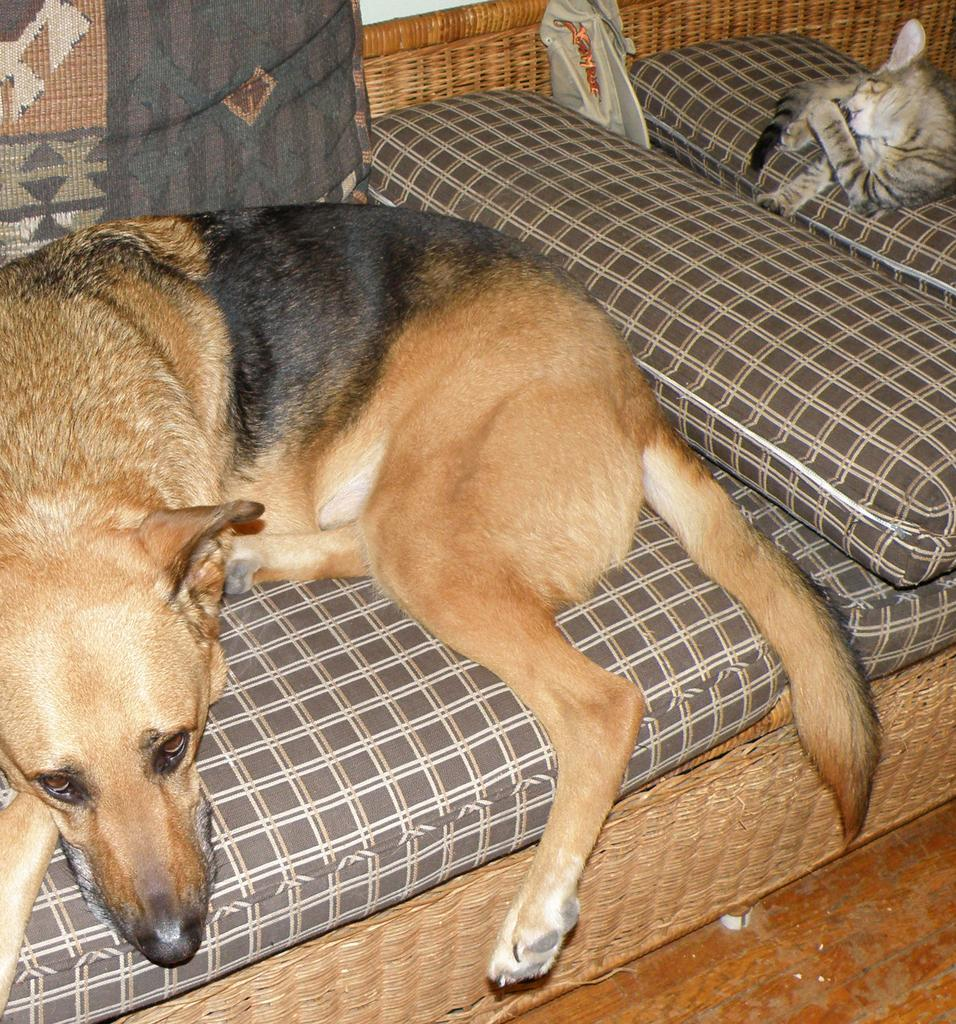What type of animal can be seen in the image? There is a dog in the image. Can you describe the appearance of the dog? The dog is brown and black in color. What other animal is present in the image? There is a cat in the image. How would you describe the appearance of the cat? The cat is white and black in color. Where are the dog and cat located in the image? Both the dog and cat are on a couch. What else can be seen near the couch in the image? There are cushions visible to the side of the couch. What type of coal is being used to make popcorn in the image? There is no coal or popcorn present in the image; it features a dog and cat on a couch. 